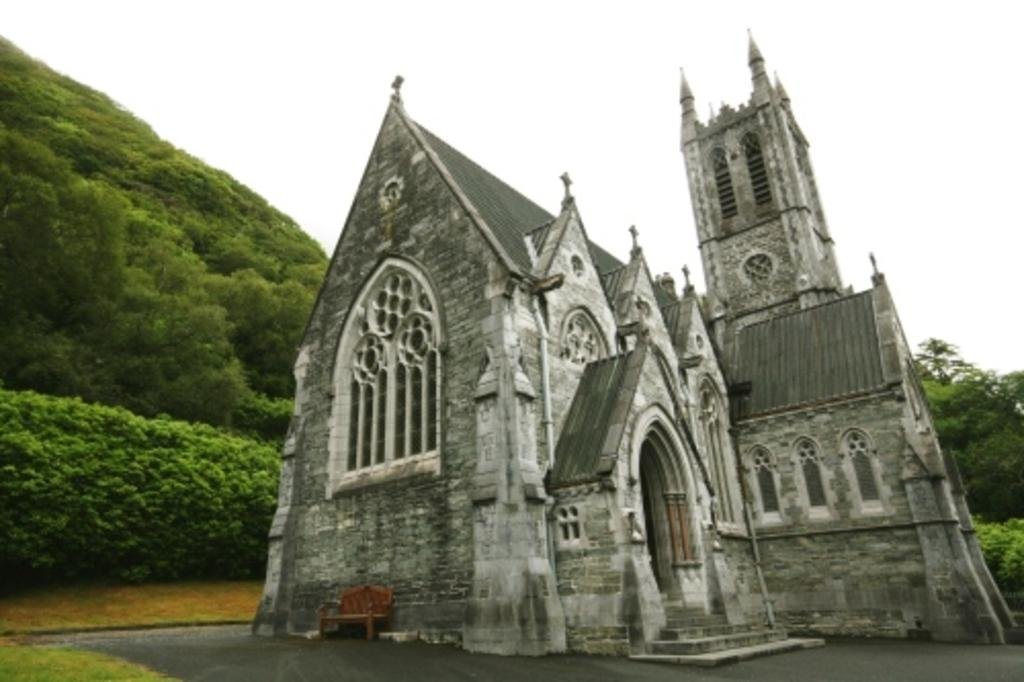What type of structure is present in the image? There is a building in the image. What is located near the building? There is a bench beside the building. What natural feature can be seen in the image? There is a mountain in the image. How is the mountain covered? The mountain is covered with trees and plants. Can you see a game of chess being played on the bench in the image? There is no game of chess visible in the image. Are there any creatures flying around the mountain in the image? There is no mention of any creatures, flying or otherwise, in the image. 